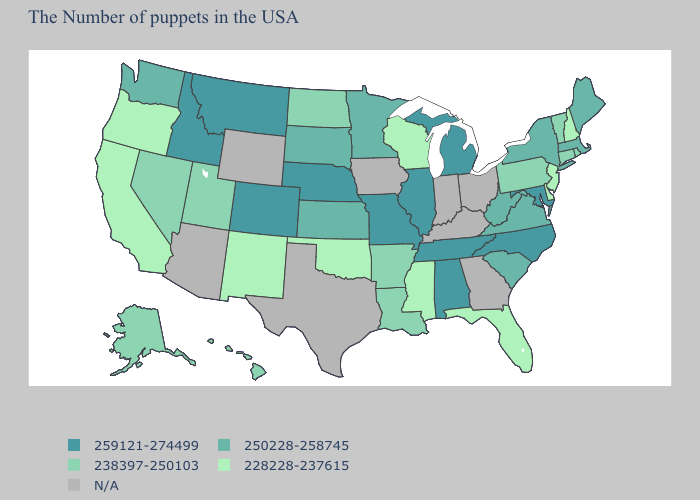Which states have the highest value in the USA?
Write a very short answer. Maryland, North Carolina, Michigan, Alabama, Tennessee, Illinois, Missouri, Nebraska, Colorado, Montana, Idaho. Does Rhode Island have the lowest value in the USA?
Short answer required. No. What is the highest value in the West ?
Concise answer only. 259121-274499. What is the value of Kansas?
Write a very short answer. 250228-258745. What is the lowest value in states that border New Hampshire?
Give a very brief answer. 238397-250103. Is the legend a continuous bar?
Be succinct. No. Among the states that border Texas , does Louisiana have the highest value?
Answer briefly. Yes. Among the states that border Minnesota , which have the highest value?
Answer briefly. South Dakota. Does the first symbol in the legend represent the smallest category?
Concise answer only. No. Name the states that have a value in the range 250228-258745?
Write a very short answer. Maine, Massachusetts, New York, Virginia, South Carolina, West Virginia, Minnesota, Kansas, South Dakota, Washington. Is the legend a continuous bar?
Keep it brief. No. What is the value of West Virginia?
Answer briefly. 250228-258745. Does Washington have the highest value in the West?
Concise answer only. No. What is the value of Alabama?
Keep it brief. 259121-274499. 